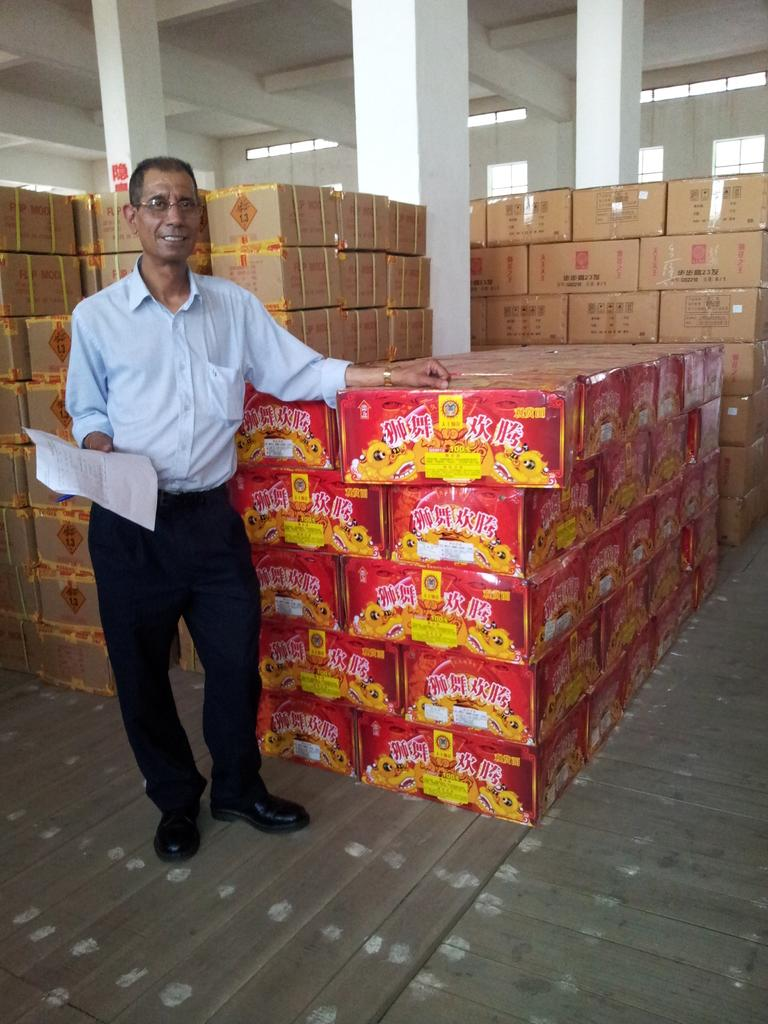What is the person in the image doing with their hand? The person is holding a paper in one hand. What can be seen in the background of the image? There are cardboard cartons arranged in rows and columns, as well as pillars visible in the background. Can you see any straws sticking out of the window in the image? There is no window present in the image, so it is not possible to see any straws sticking out of it. 